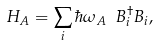<formula> <loc_0><loc_0><loc_500><loc_500>H _ { A } = \sum _ { i } \hbar { \omega } _ { A } \ B _ { i } ^ { \dagger } B _ { i } ,</formula> 